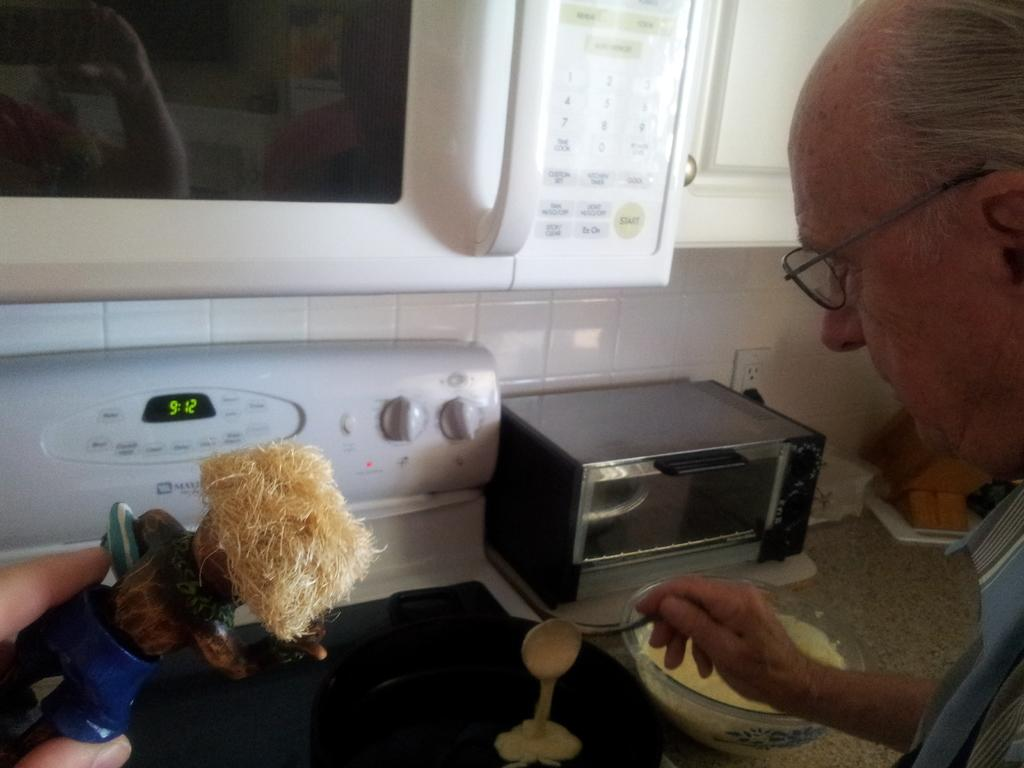<image>
Summarize the visual content of the image. A man cooks on a stove that says the time is 9:12. 